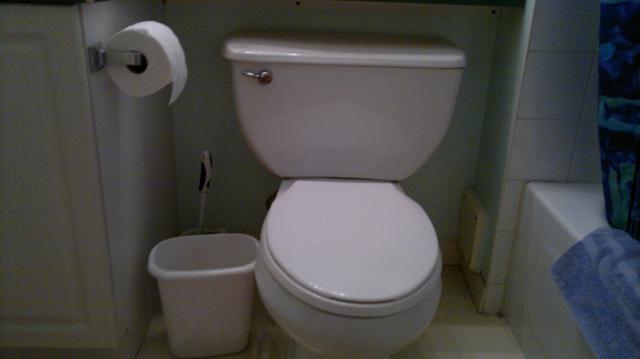How many toilets are there?
Give a very brief answer. 1. How many rolls of toilet paper are here?
Give a very brief answer. 1. How many rolls of toilet paper are shown?
Give a very brief answer. 1. How many extra rolls of toilet paper are being stored here?
Give a very brief answer. 0. How many rolls of toilet paper in this scene?
Give a very brief answer. 1. 